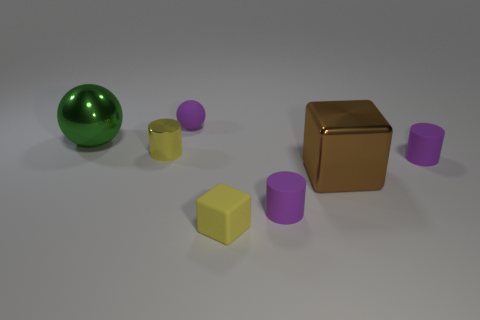Is there anything else that has the same size as the green sphere?
Give a very brief answer. Yes. There is a purple rubber object on the right side of the big block; is its shape the same as the yellow rubber thing?
Your answer should be compact. No. What number of objects are behind the small yellow cylinder and left of the purple matte sphere?
Offer a very short reply. 1. What color is the big shiny thing in front of the green metallic object in front of the ball on the right side of the large green sphere?
Provide a succinct answer. Brown. How many tiny rubber spheres are behind the big object that is to the left of the tiny shiny object?
Make the answer very short. 1. How many other things are there of the same shape as the green metallic object?
Ensure brevity in your answer.  1. What number of things are either purple objects or tiny yellow cubes that are to the left of the large metallic cube?
Your answer should be very brief. 4. Is the number of yellow metal cylinders in front of the small block greater than the number of blocks behind the metallic cube?
Make the answer very short. No. The big metallic object that is on the left side of the purple rubber thing behind the big thing that is on the left side of the small purple ball is what shape?
Make the answer very short. Sphere. There is a small purple object behind the purple cylinder behind the brown object; what is its shape?
Provide a succinct answer. Sphere. 